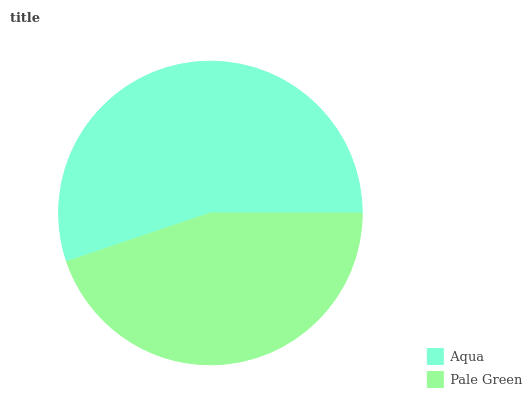Is Pale Green the minimum?
Answer yes or no. Yes. Is Aqua the maximum?
Answer yes or no. Yes. Is Pale Green the maximum?
Answer yes or no. No. Is Aqua greater than Pale Green?
Answer yes or no. Yes. Is Pale Green less than Aqua?
Answer yes or no. Yes. Is Pale Green greater than Aqua?
Answer yes or no. No. Is Aqua less than Pale Green?
Answer yes or no. No. Is Aqua the high median?
Answer yes or no. Yes. Is Pale Green the low median?
Answer yes or no. Yes. Is Pale Green the high median?
Answer yes or no. No. Is Aqua the low median?
Answer yes or no. No. 